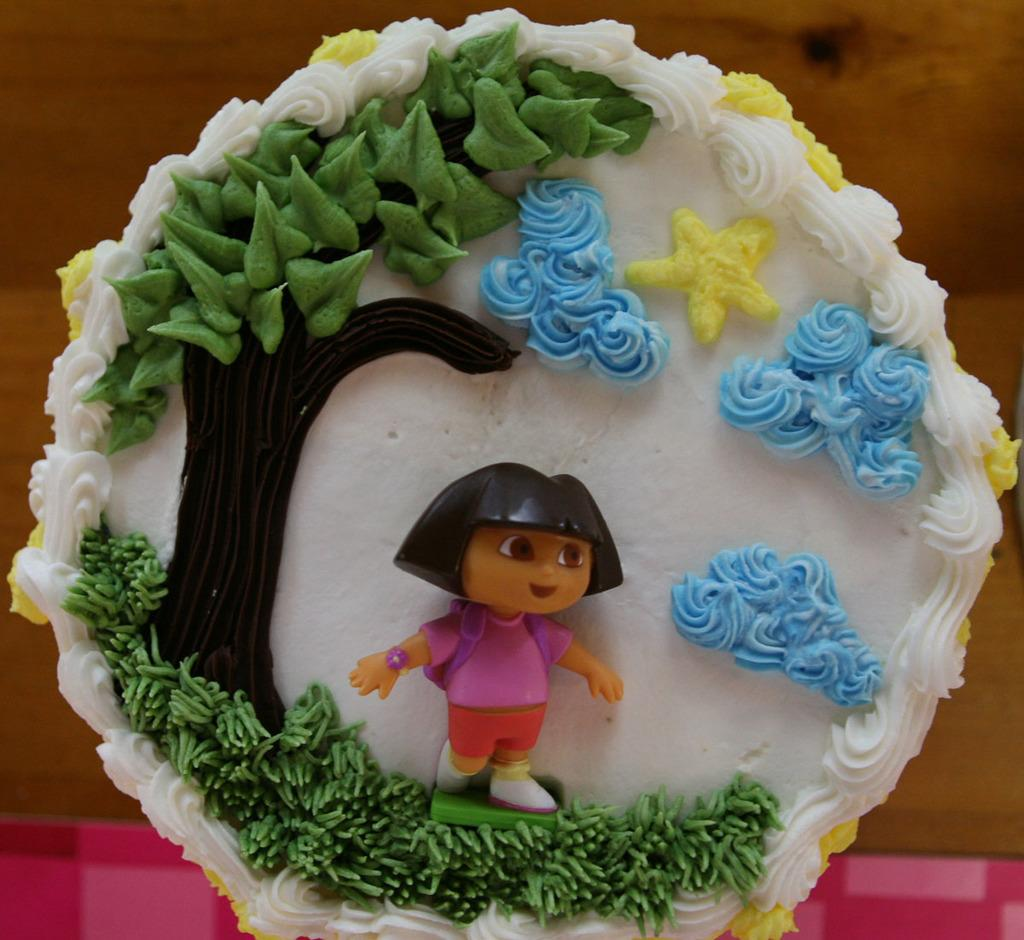What is the main subject of the image? There is a cake in the image. Where is the cake located? The cake is on a table. How many ants are crawling on the cake in the image? There are no ants visible on the cake in the image. What type of horn is used to decorate the cake in the image? There is no horn present on the cake in the image. 